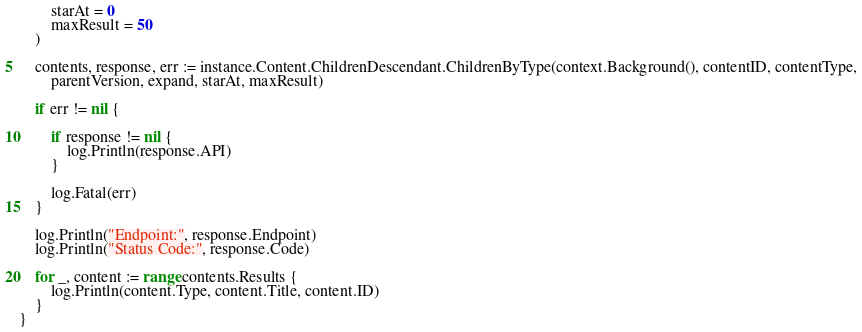Convert code to text. <code><loc_0><loc_0><loc_500><loc_500><_Go_>		starAt = 0
		maxResult = 50
	)

	contents, response, err := instance.Content.ChildrenDescendant.ChildrenByType(context.Background(), contentID, contentType,
		parentVersion, expand, starAt, maxResult)

	if err != nil {

		if response != nil {
			log.Println(response.API)
		}

		log.Fatal(err)
	}

	log.Println("Endpoint:", response.Endpoint)
	log.Println("Status Code:", response.Code)

	for _, content := range contents.Results {
		log.Println(content.Type, content.Title, content.ID)
	}
}
</code> 